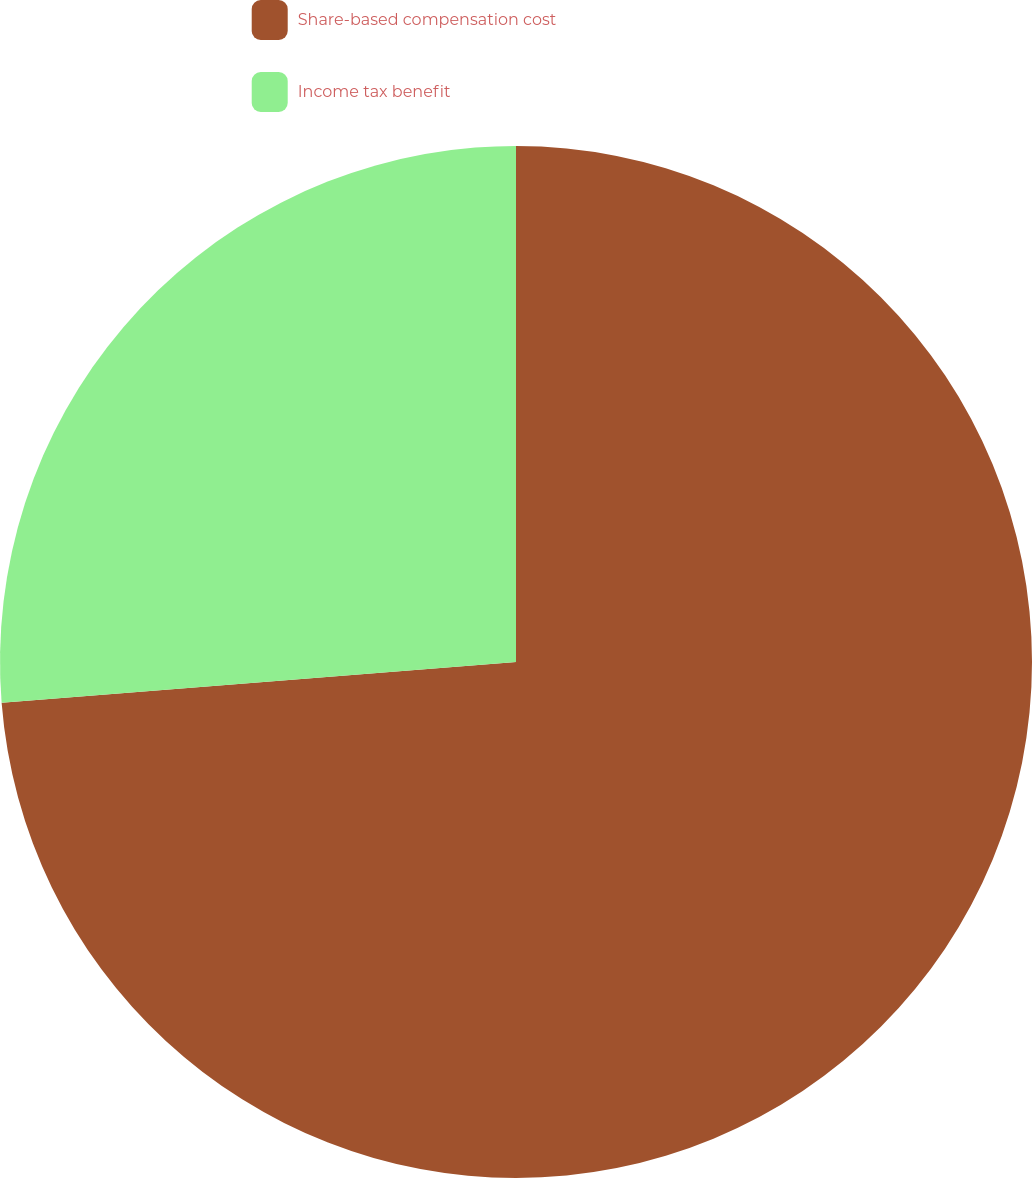Convert chart to OTSL. <chart><loc_0><loc_0><loc_500><loc_500><pie_chart><fcel>Share-based compensation cost<fcel>Income tax benefit<nl><fcel>73.74%<fcel>26.26%<nl></chart> 